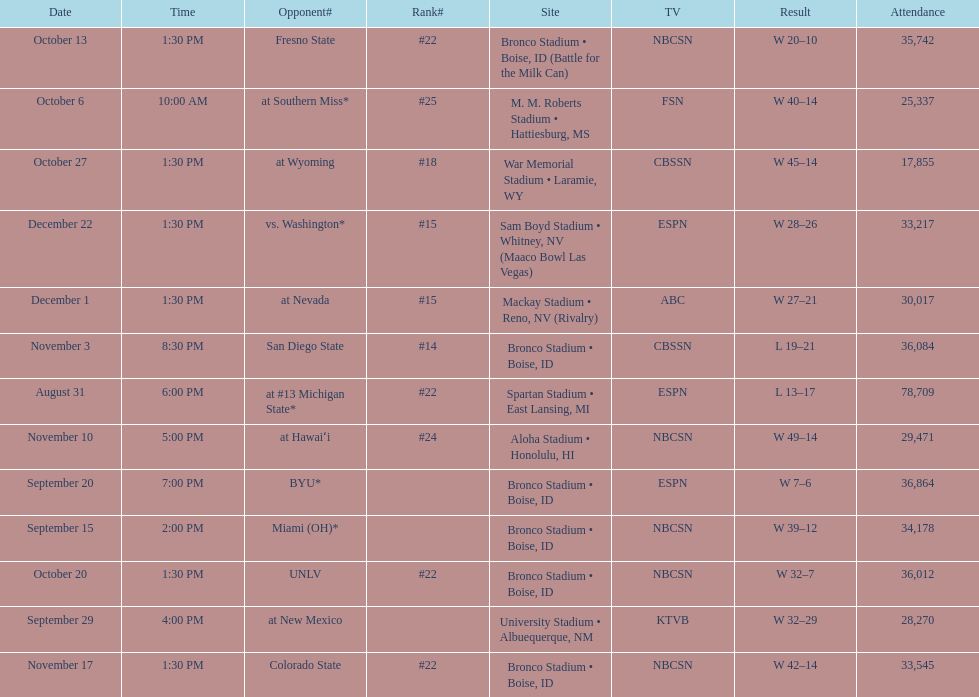What rank was boise state after november 10th? #22. 